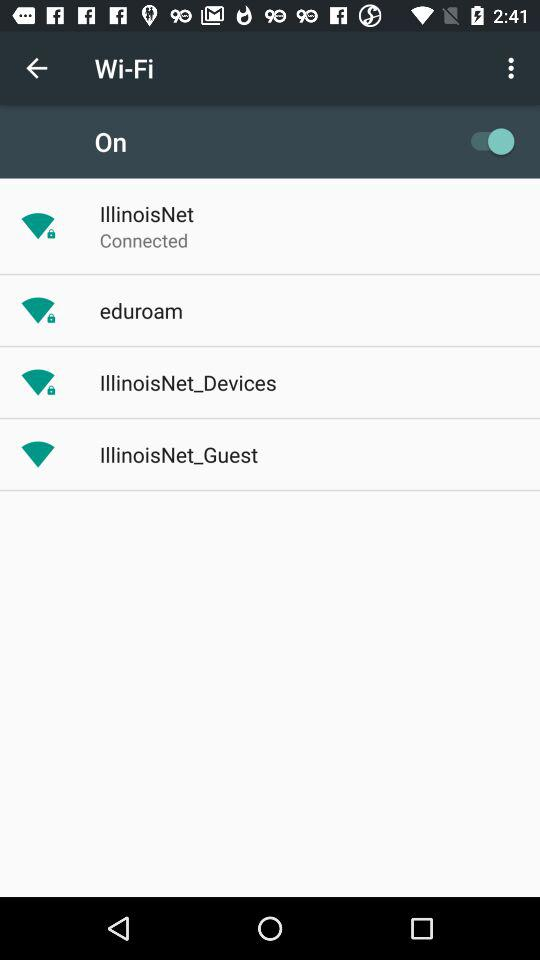What is the password for the WiFi?
When the provided information is insufficient, respond with <no answer>. <no answer> 